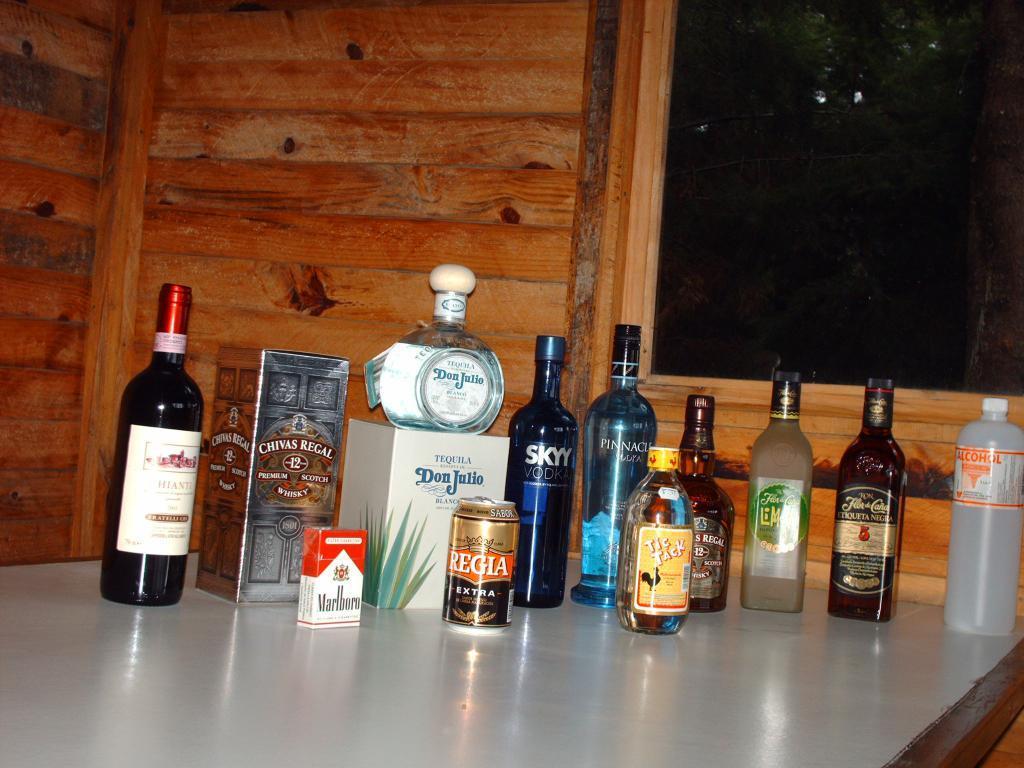Can you describe this image briefly? In this picture there are bottles kept on the table. In the background there is a wooden wall and there is a window on the right. 